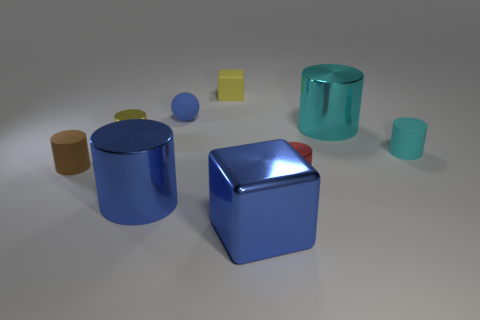Subtract all big blue metal cylinders. How many cylinders are left? 5 Subtract all blue cylinders. How many cylinders are left? 5 Subtract 1 blocks. How many blocks are left? 1 Add 1 cyan rubber things. How many objects exist? 10 Subtract all cylinders. How many objects are left? 3 Add 1 small purple rubber blocks. How many small purple rubber blocks exist? 1 Subtract 1 red cylinders. How many objects are left? 8 Subtract all yellow blocks. Subtract all red spheres. How many blocks are left? 1 Subtract all gray cubes. How many gray balls are left? 0 Subtract all tiny blue objects. Subtract all large blue metallic things. How many objects are left? 6 